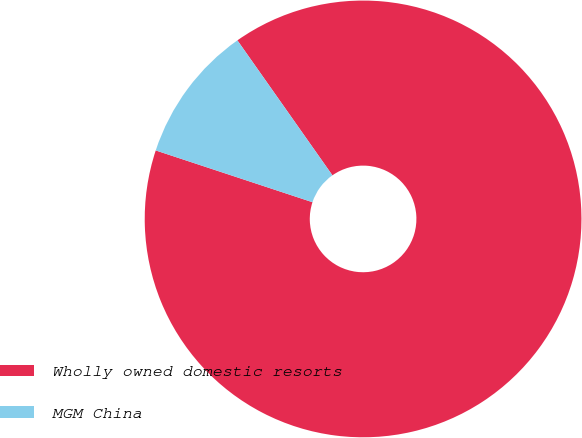Convert chart. <chart><loc_0><loc_0><loc_500><loc_500><pie_chart><fcel>Wholly owned domestic resorts<fcel>MGM China<nl><fcel>89.84%<fcel>10.16%<nl></chart> 